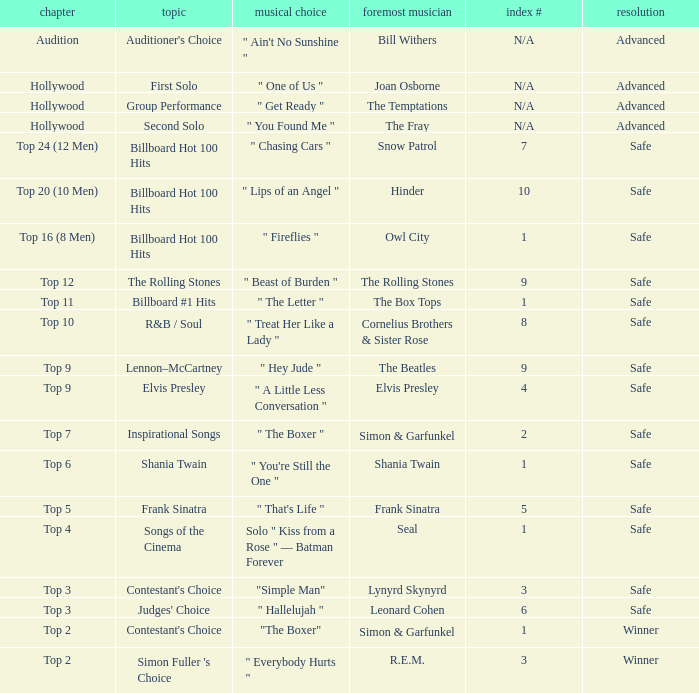The theme Auditioner's Choice	has what song choice? " Ain't No Sunshine ". 